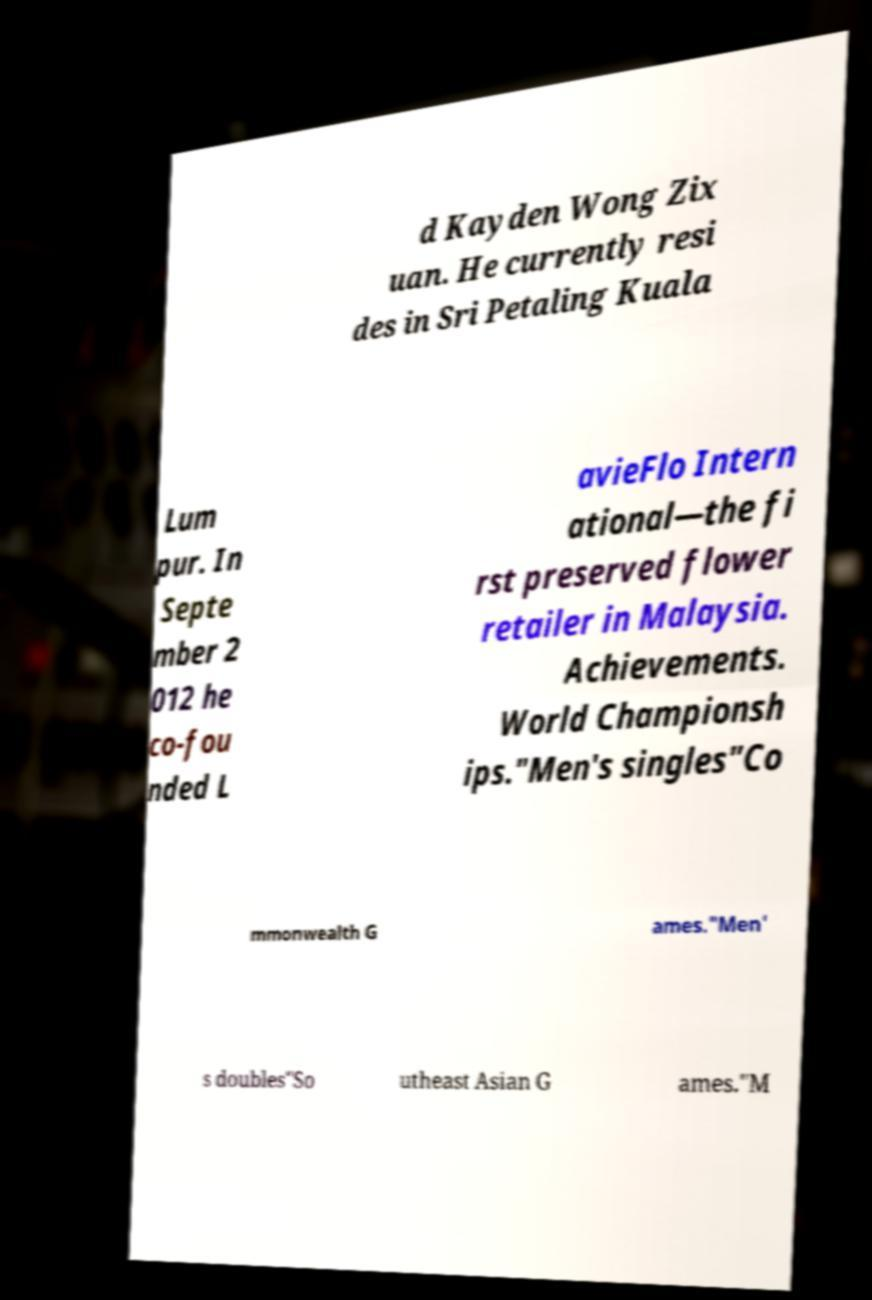I need the written content from this picture converted into text. Can you do that? d Kayden Wong Zix uan. He currently resi des in Sri Petaling Kuala Lum pur. In Septe mber 2 012 he co-fou nded L avieFlo Intern ational—the fi rst preserved flower retailer in Malaysia. Achievements. World Championsh ips."Men's singles"Co mmonwealth G ames."Men' s doubles"So utheast Asian G ames."M 